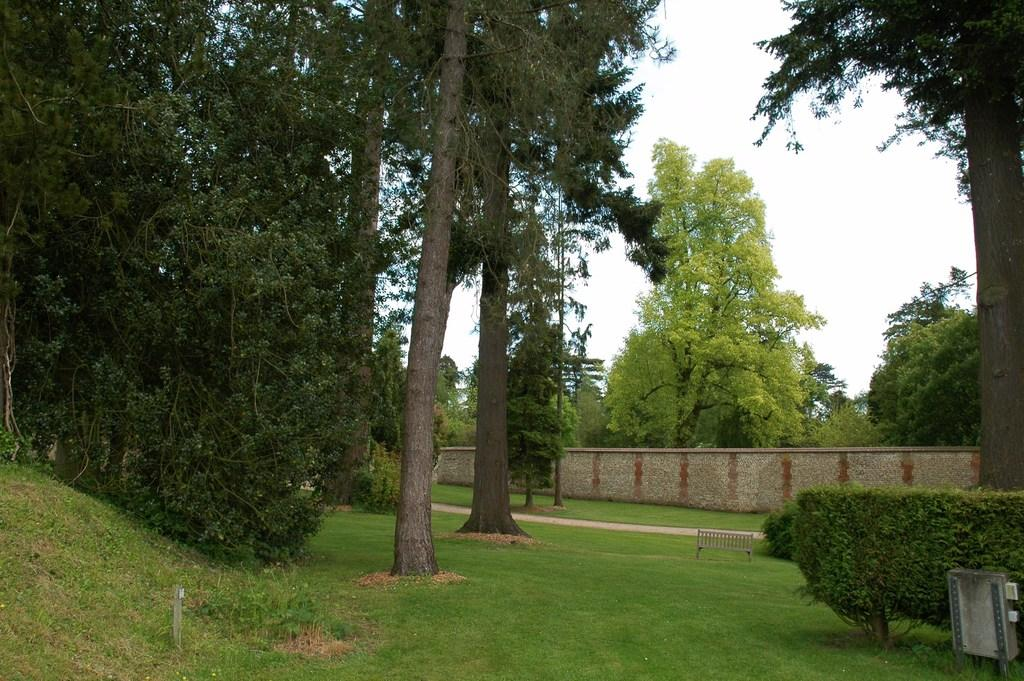What type of vegetation can be seen in the image? There are trees and grass in the image. What type of seating is present in the image? There is a bench in the image. What architectural feature can be seen in the image? There is a wall in the image. Where is the box located in the image? The box is at the right bottom of the image. Can you describe the goose sitting on the branch in the image? There is no goose or branch present in the image. What type of ball is visible in the image? There is no ball present in the image. 